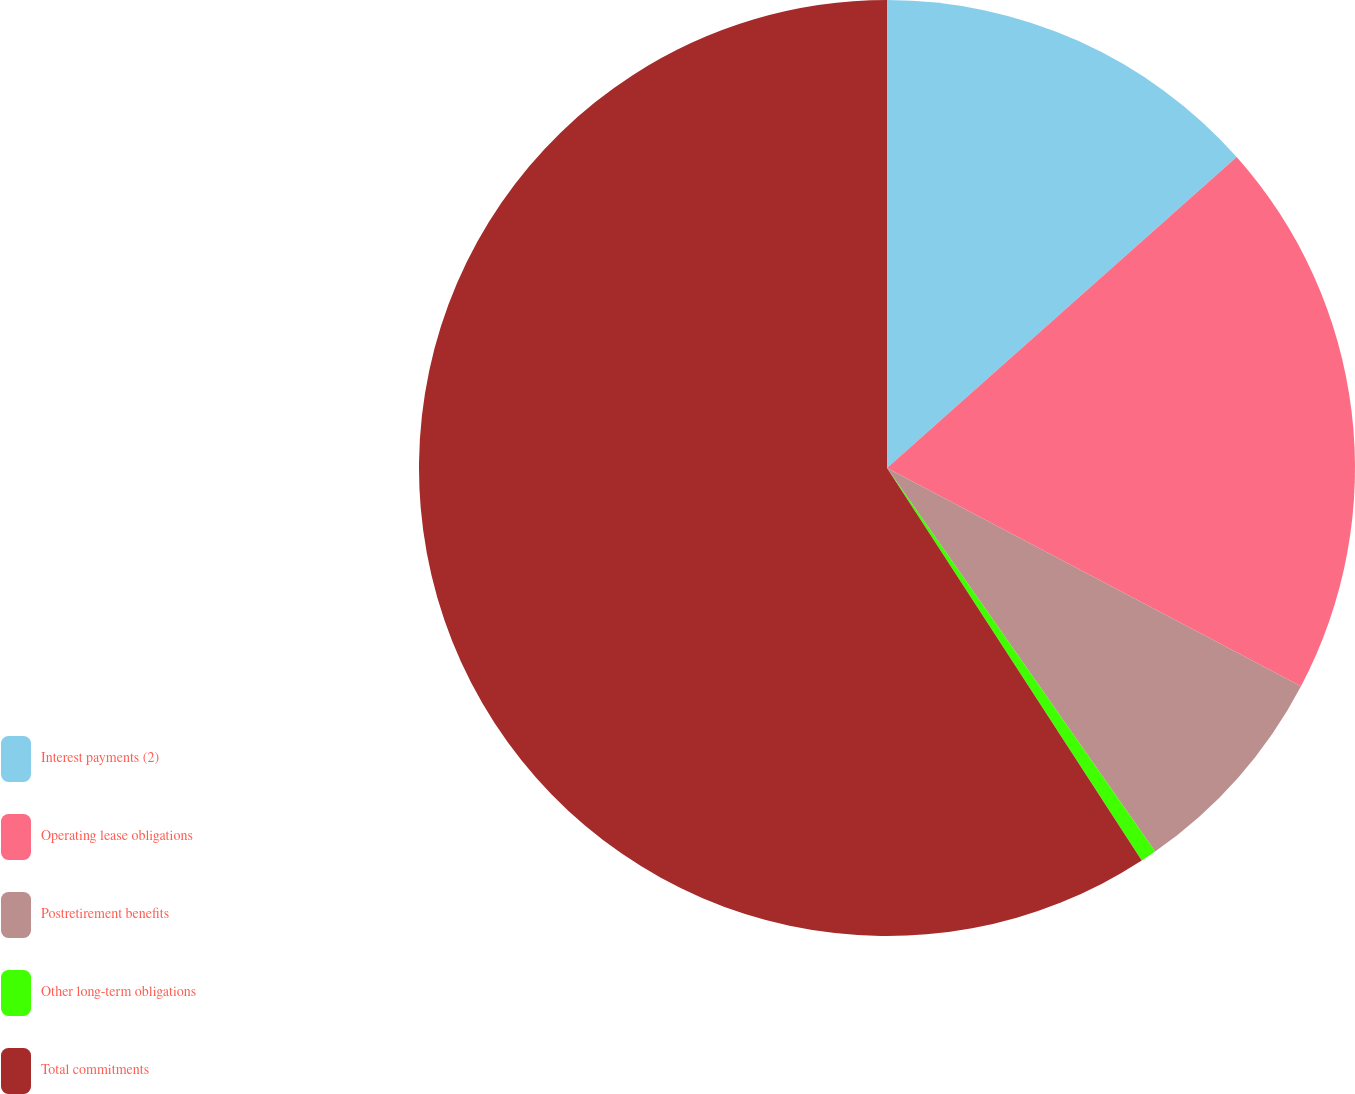Convert chart. <chart><loc_0><loc_0><loc_500><loc_500><pie_chart><fcel>Interest payments (2)<fcel>Operating lease obligations<fcel>Postretirement benefits<fcel>Other long-term obligations<fcel>Total commitments<nl><fcel>13.43%<fcel>19.29%<fcel>7.57%<fcel>0.55%<fcel>59.16%<nl></chart> 